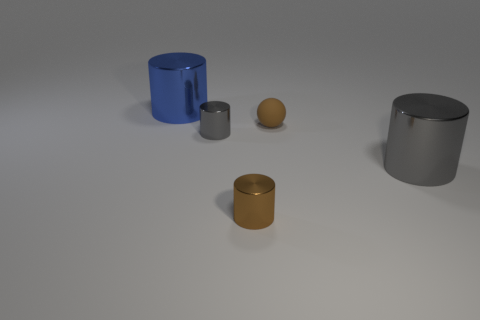Are the large gray thing and the tiny ball made of the same material?
Ensure brevity in your answer.  No. What size is the object that is both behind the tiny gray metal cylinder and to the right of the brown shiny thing?
Provide a short and direct response. Small. How many objects have the same size as the brown ball?
Offer a terse response. 2. There is a cylinder behind the gray metal object behind the large gray object; what size is it?
Offer a terse response. Large. There is a small metal object left of the tiny brown shiny cylinder; is its shape the same as the gray metallic object on the right side of the small gray cylinder?
Your response must be concise. Yes. There is a object that is both behind the large gray metal thing and in front of the tiny matte thing; what is its color?
Your response must be concise. Gray. Are there any large metal objects of the same color as the small matte sphere?
Keep it short and to the point. No. There is a thing right of the small brown sphere; what color is it?
Provide a short and direct response. Gray. Is there a object that is behind the tiny metal cylinder that is in front of the small gray thing?
Keep it short and to the point. Yes. There is a tiny rubber thing; does it have the same color as the big object in front of the blue metallic cylinder?
Offer a terse response. No. 